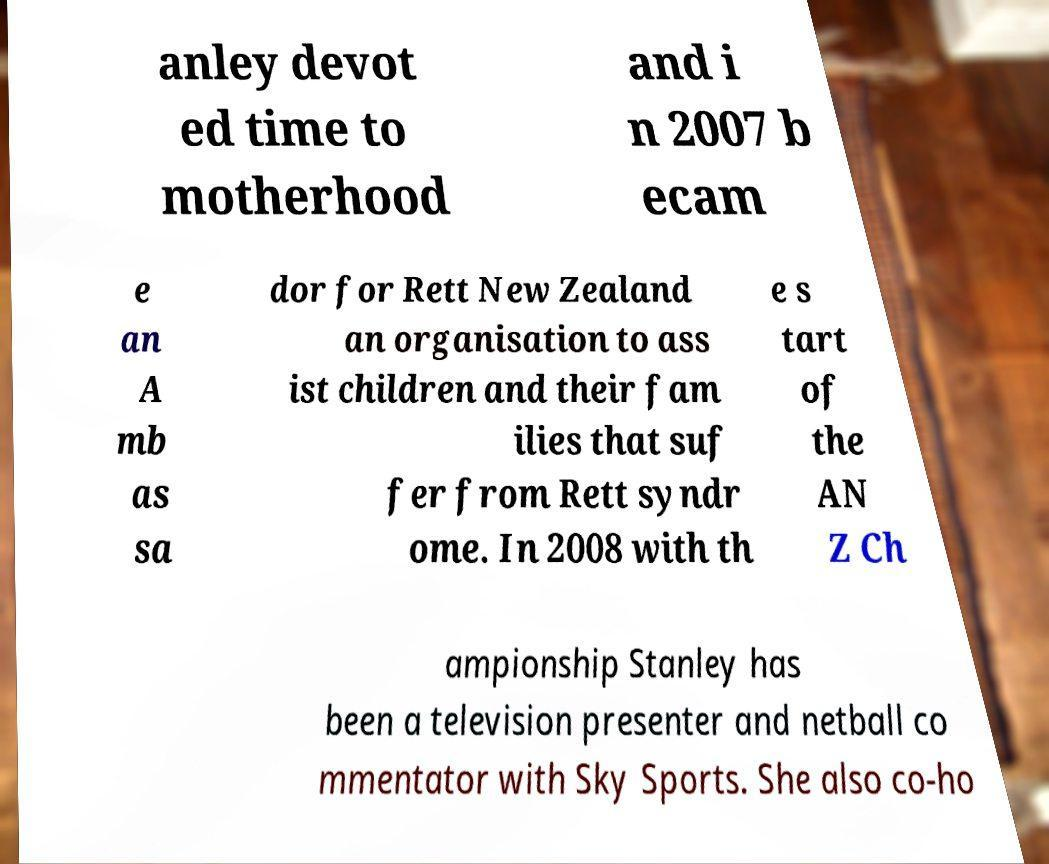Can you accurately transcribe the text from the provided image for me? anley devot ed time to motherhood and i n 2007 b ecam e an A mb as sa dor for Rett New Zealand an organisation to ass ist children and their fam ilies that suf fer from Rett syndr ome. In 2008 with th e s tart of the AN Z Ch ampionship Stanley has been a television presenter and netball co mmentator with Sky Sports. She also co-ho 